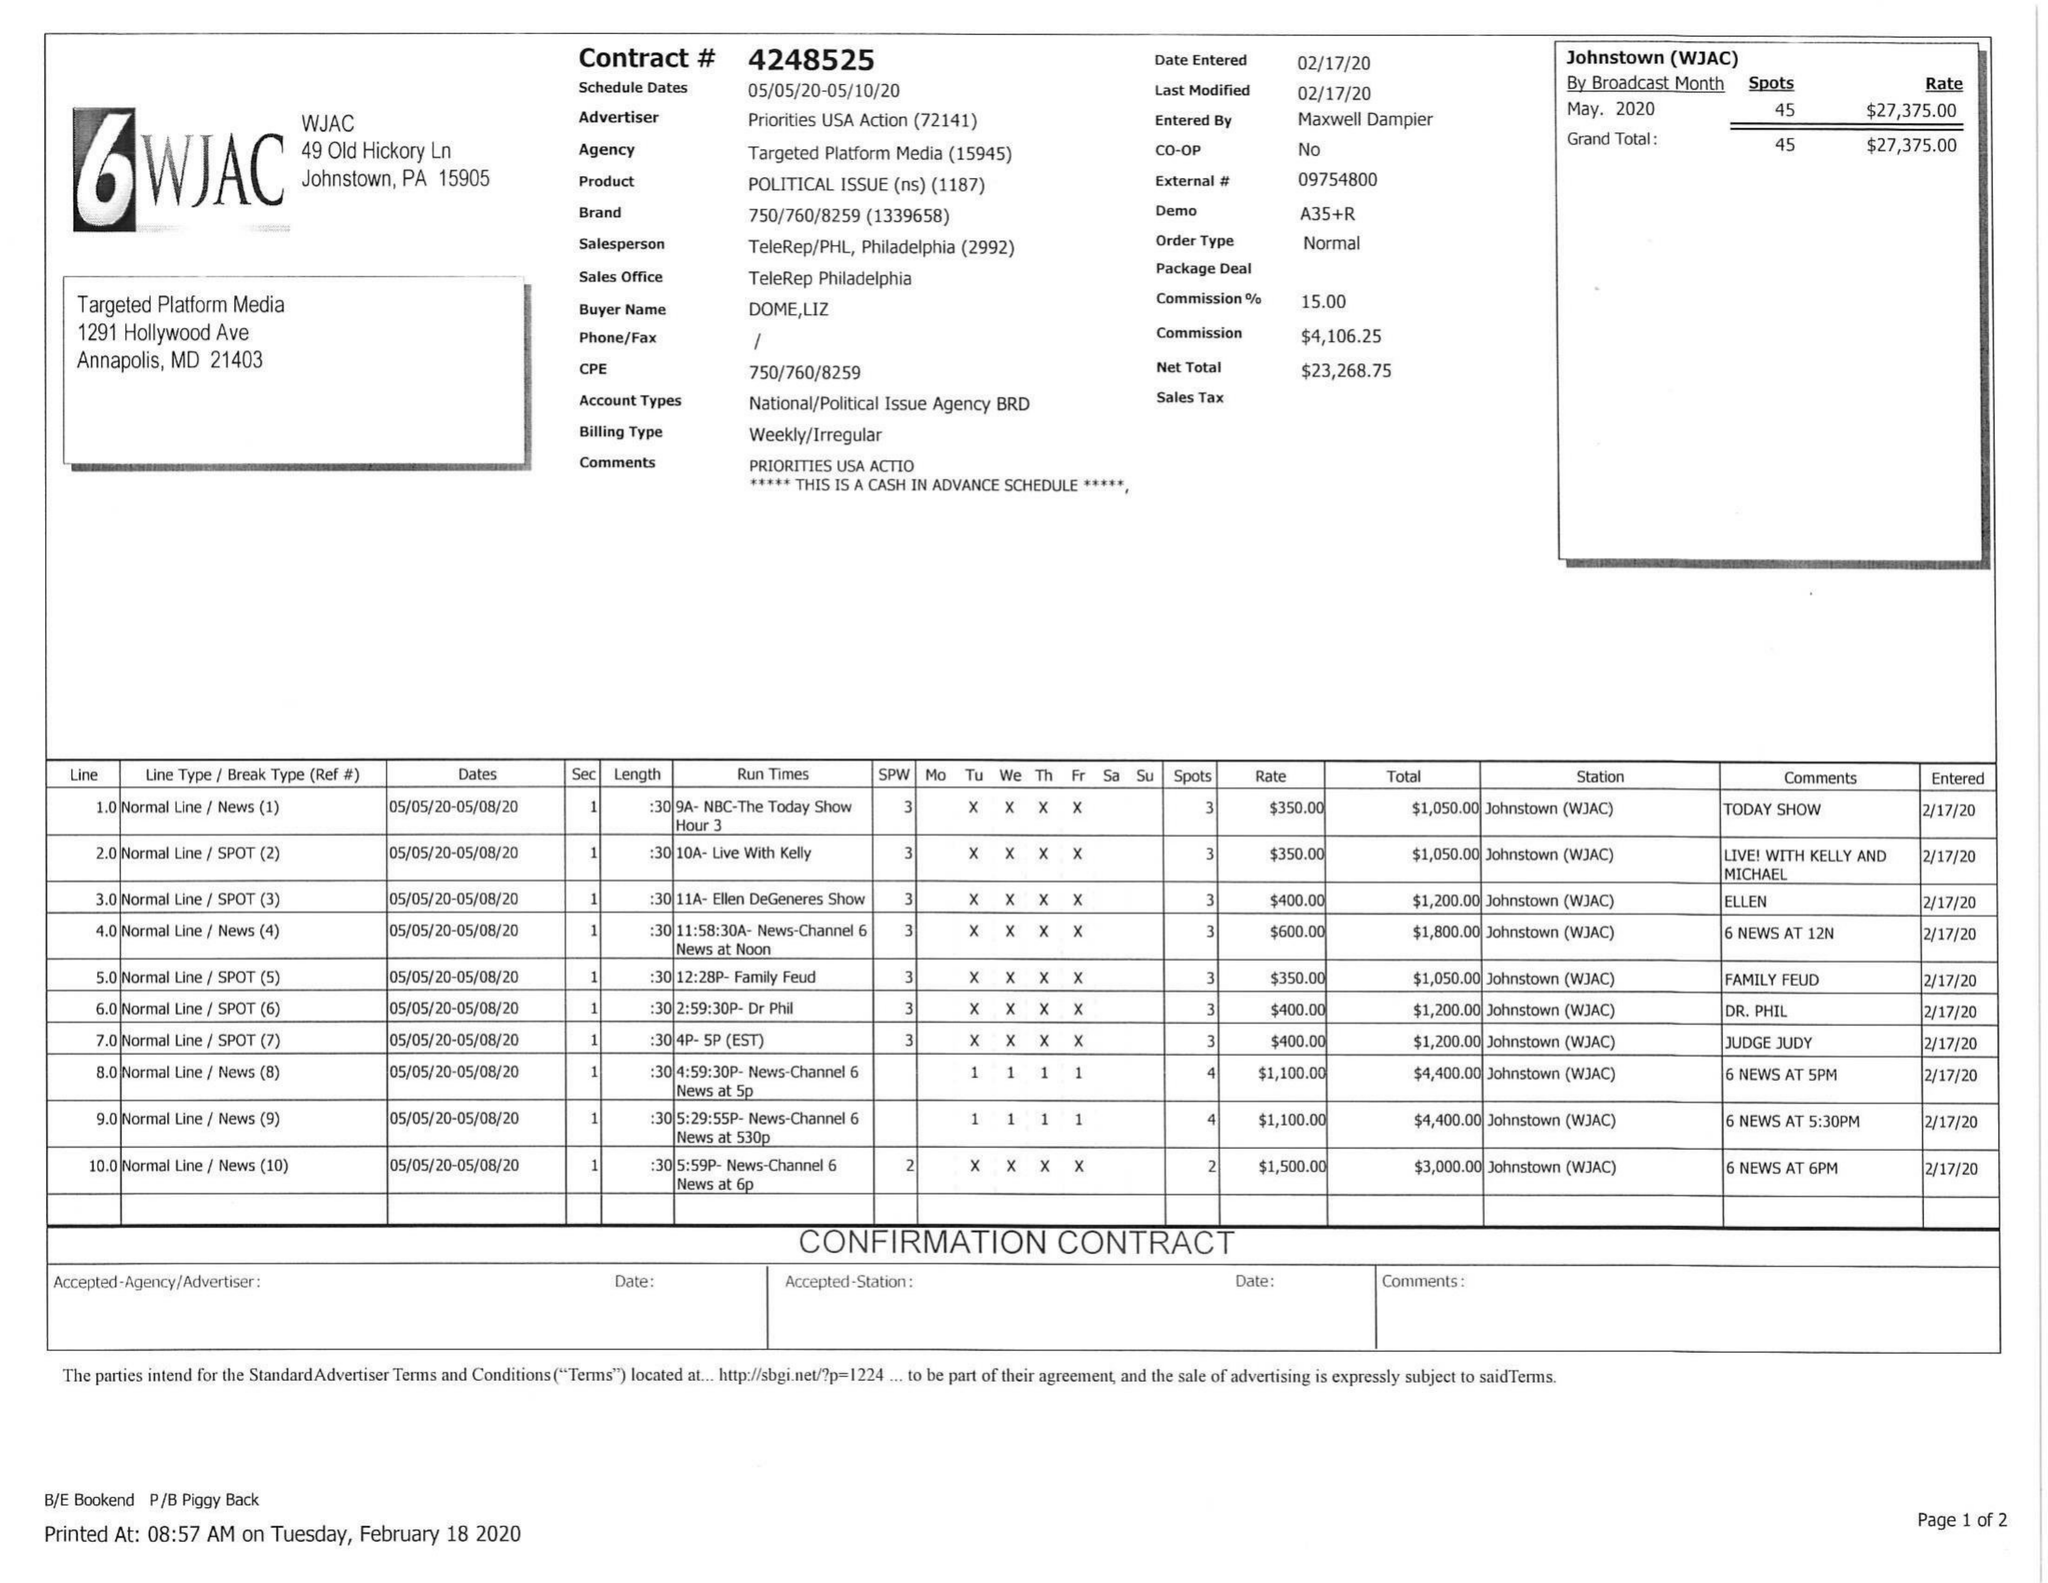What is the value for the flight_from?
Answer the question using a single word or phrase. 05/05/20 